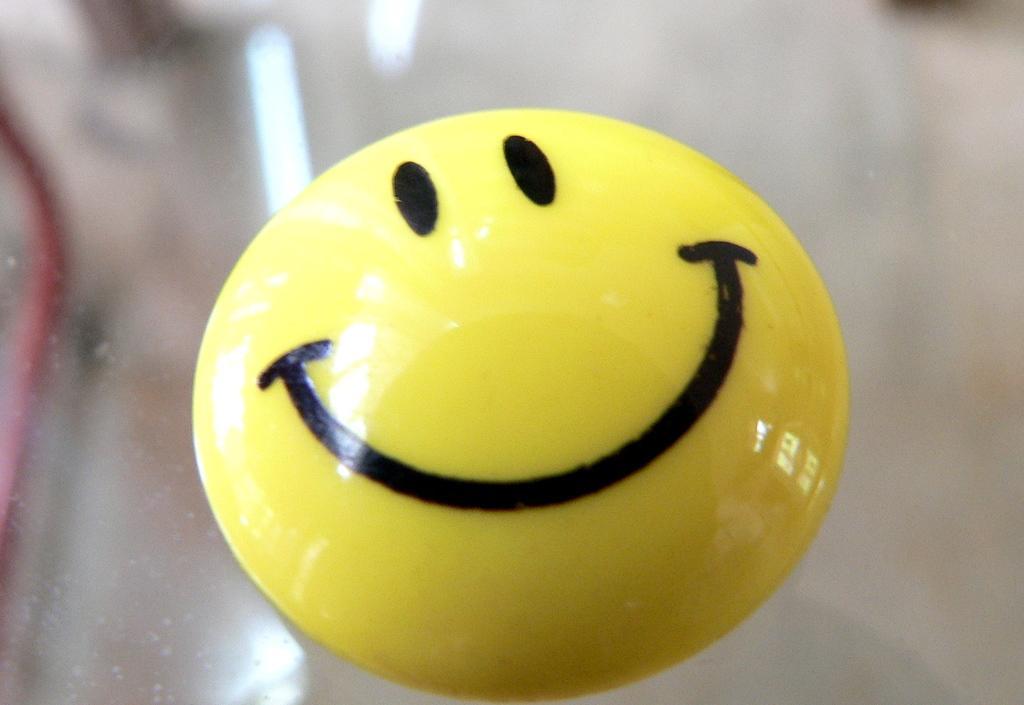Please provide a concise description of this image. In this image we can see a smiley badge on a glass platform and at the top we can see the reflections of lights and an object on the glass platform. 